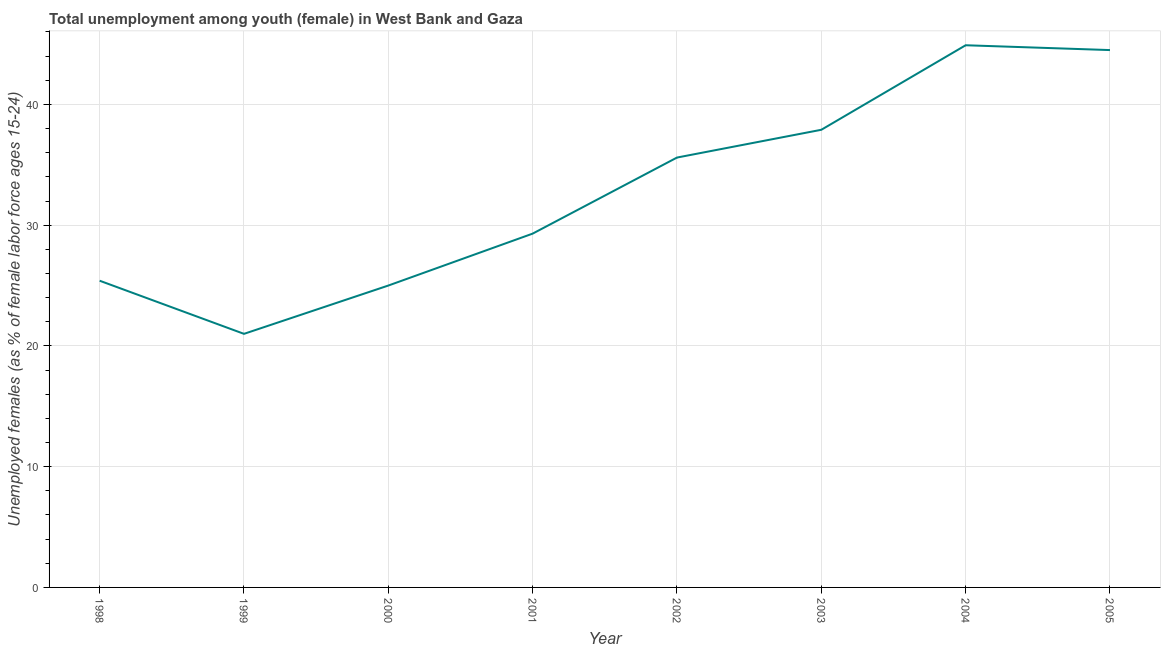What is the unemployed female youth population in 2002?
Make the answer very short. 35.6. Across all years, what is the maximum unemployed female youth population?
Offer a terse response. 44.9. Across all years, what is the minimum unemployed female youth population?
Keep it short and to the point. 21. In which year was the unemployed female youth population maximum?
Make the answer very short. 2004. What is the sum of the unemployed female youth population?
Your answer should be compact. 263.6. What is the difference between the unemployed female youth population in 2001 and 2003?
Make the answer very short. -8.6. What is the average unemployed female youth population per year?
Your answer should be very brief. 32.95. What is the median unemployed female youth population?
Your answer should be compact. 32.45. What is the ratio of the unemployed female youth population in 2000 to that in 2004?
Your answer should be compact. 0.56. Is the difference between the unemployed female youth population in 2000 and 2005 greater than the difference between any two years?
Make the answer very short. No. What is the difference between the highest and the second highest unemployed female youth population?
Offer a terse response. 0.4. What is the difference between the highest and the lowest unemployed female youth population?
Make the answer very short. 23.9. In how many years, is the unemployed female youth population greater than the average unemployed female youth population taken over all years?
Ensure brevity in your answer.  4. Does the unemployed female youth population monotonically increase over the years?
Your response must be concise. No. What is the difference between two consecutive major ticks on the Y-axis?
Offer a terse response. 10. Are the values on the major ticks of Y-axis written in scientific E-notation?
Your answer should be very brief. No. What is the title of the graph?
Ensure brevity in your answer.  Total unemployment among youth (female) in West Bank and Gaza. What is the label or title of the Y-axis?
Make the answer very short. Unemployed females (as % of female labor force ages 15-24). What is the Unemployed females (as % of female labor force ages 15-24) of 1998?
Provide a short and direct response. 25.4. What is the Unemployed females (as % of female labor force ages 15-24) of 2001?
Your response must be concise. 29.3. What is the Unemployed females (as % of female labor force ages 15-24) of 2002?
Your answer should be very brief. 35.6. What is the Unemployed females (as % of female labor force ages 15-24) of 2003?
Offer a terse response. 37.9. What is the Unemployed females (as % of female labor force ages 15-24) of 2004?
Offer a terse response. 44.9. What is the Unemployed females (as % of female labor force ages 15-24) of 2005?
Your answer should be compact. 44.5. What is the difference between the Unemployed females (as % of female labor force ages 15-24) in 1998 and 2002?
Offer a very short reply. -10.2. What is the difference between the Unemployed females (as % of female labor force ages 15-24) in 1998 and 2003?
Ensure brevity in your answer.  -12.5. What is the difference between the Unemployed females (as % of female labor force ages 15-24) in 1998 and 2004?
Your answer should be compact. -19.5. What is the difference between the Unemployed females (as % of female labor force ages 15-24) in 1998 and 2005?
Keep it short and to the point. -19.1. What is the difference between the Unemployed females (as % of female labor force ages 15-24) in 1999 and 2000?
Ensure brevity in your answer.  -4. What is the difference between the Unemployed females (as % of female labor force ages 15-24) in 1999 and 2002?
Keep it short and to the point. -14.6. What is the difference between the Unemployed females (as % of female labor force ages 15-24) in 1999 and 2003?
Keep it short and to the point. -16.9. What is the difference between the Unemployed females (as % of female labor force ages 15-24) in 1999 and 2004?
Your response must be concise. -23.9. What is the difference between the Unemployed females (as % of female labor force ages 15-24) in 1999 and 2005?
Your answer should be compact. -23.5. What is the difference between the Unemployed females (as % of female labor force ages 15-24) in 2000 and 2001?
Your answer should be compact. -4.3. What is the difference between the Unemployed females (as % of female labor force ages 15-24) in 2000 and 2003?
Provide a short and direct response. -12.9. What is the difference between the Unemployed females (as % of female labor force ages 15-24) in 2000 and 2004?
Your response must be concise. -19.9. What is the difference between the Unemployed females (as % of female labor force ages 15-24) in 2000 and 2005?
Offer a very short reply. -19.5. What is the difference between the Unemployed females (as % of female labor force ages 15-24) in 2001 and 2002?
Give a very brief answer. -6.3. What is the difference between the Unemployed females (as % of female labor force ages 15-24) in 2001 and 2003?
Your answer should be compact. -8.6. What is the difference between the Unemployed females (as % of female labor force ages 15-24) in 2001 and 2004?
Your answer should be compact. -15.6. What is the difference between the Unemployed females (as % of female labor force ages 15-24) in 2001 and 2005?
Ensure brevity in your answer.  -15.2. What is the difference between the Unemployed females (as % of female labor force ages 15-24) in 2002 and 2003?
Your answer should be very brief. -2.3. What is the ratio of the Unemployed females (as % of female labor force ages 15-24) in 1998 to that in 1999?
Your response must be concise. 1.21. What is the ratio of the Unemployed females (as % of female labor force ages 15-24) in 1998 to that in 2000?
Offer a terse response. 1.02. What is the ratio of the Unemployed females (as % of female labor force ages 15-24) in 1998 to that in 2001?
Offer a terse response. 0.87. What is the ratio of the Unemployed females (as % of female labor force ages 15-24) in 1998 to that in 2002?
Make the answer very short. 0.71. What is the ratio of the Unemployed females (as % of female labor force ages 15-24) in 1998 to that in 2003?
Provide a short and direct response. 0.67. What is the ratio of the Unemployed females (as % of female labor force ages 15-24) in 1998 to that in 2004?
Make the answer very short. 0.57. What is the ratio of the Unemployed females (as % of female labor force ages 15-24) in 1998 to that in 2005?
Make the answer very short. 0.57. What is the ratio of the Unemployed females (as % of female labor force ages 15-24) in 1999 to that in 2000?
Ensure brevity in your answer.  0.84. What is the ratio of the Unemployed females (as % of female labor force ages 15-24) in 1999 to that in 2001?
Your answer should be compact. 0.72. What is the ratio of the Unemployed females (as % of female labor force ages 15-24) in 1999 to that in 2002?
Give a very brief answer. 0.59. What is the ratio of the Unemployed females (as % of female labor force ages 15-24) in 1999 to that in 2003?
Keep it short and to the point. 0.55. What is the ratio of the Unemployed females (as % of female labor force ages 15-24) in 1999 to that in 2004?
Offer a terse response. 0.47. What is the ratio of the Unemployed females (as % of female labor force ages 15-24) in 1999 to that in 2005?
Make the answer very short. 0.47. What is the ratio of the Unemployed females (as % of female labor force ages 15-24) in 2000 to that in 2001?
Give a very brief answer. 0.85. What is the ratio of the Unemployed females (as % of female labor force ages 15-24) in 2000 to that in 2002?
Make the answer very short. 0.7. What is the ratio of the Unemployed females (as % of female labor force ages 15-24) in 2000 to that in 2003?
Provide a short and direct response. 0.66. What is the ratio of the Unemployed females (as % of female labor force ages 15-24) in 2000 to that in 2004?
Give a very brief answer. 0.56. What is the ratio of the Unemployed females (as % of female labor force ages 15-24) in 2000 to that in 2005?
Make the answer very short. 0.56. What is the ratio of the Unemployed females (as % of female labor force ages 15-24) in 2001 to that in 2002?
Provide a succinct answer. 0.82. What is the ratio of the Unemployed females (as % of female labor force ages 15-24) in 2001 to that in 2003?
Offer a terse response. 0.77. What is the ratio of the Unemployed females (as % of female labor force ages 15-24) in 2001 to that in 2004?
Make the answer very short. 0.65. What is the ratio of the Unemployed females (as % of female labor force ages 15-24) in 2001 to that in 2005?
Your answer should be compact. 0.66. What is the ratio of the Unemployed females (as % of female labor force ages 15-24) in 2002 to that in 2003?
Provide a short and direct response. 0.94. What is the ratio of the Unemployed females (as % of female labor force ages 15-24) in 2002 to that in 2004?
Provide a succinct answer. 0.79. What is the ratio of the Unemployed females (as % of female labor force ages 15-24) in 2003 to that in 2004?
Your response must be concise. 0.84. What is the ratio of the Unemployed females (as % of female labor force ages 15-24) in 2003 to that in 2005?
Your answer should be compact. 0.85. What is the ratio of the Unemployed females (as % of female labor force ages 15-24) in 2004 to that in 2005?
Provide a succinct answer. 1.01. 